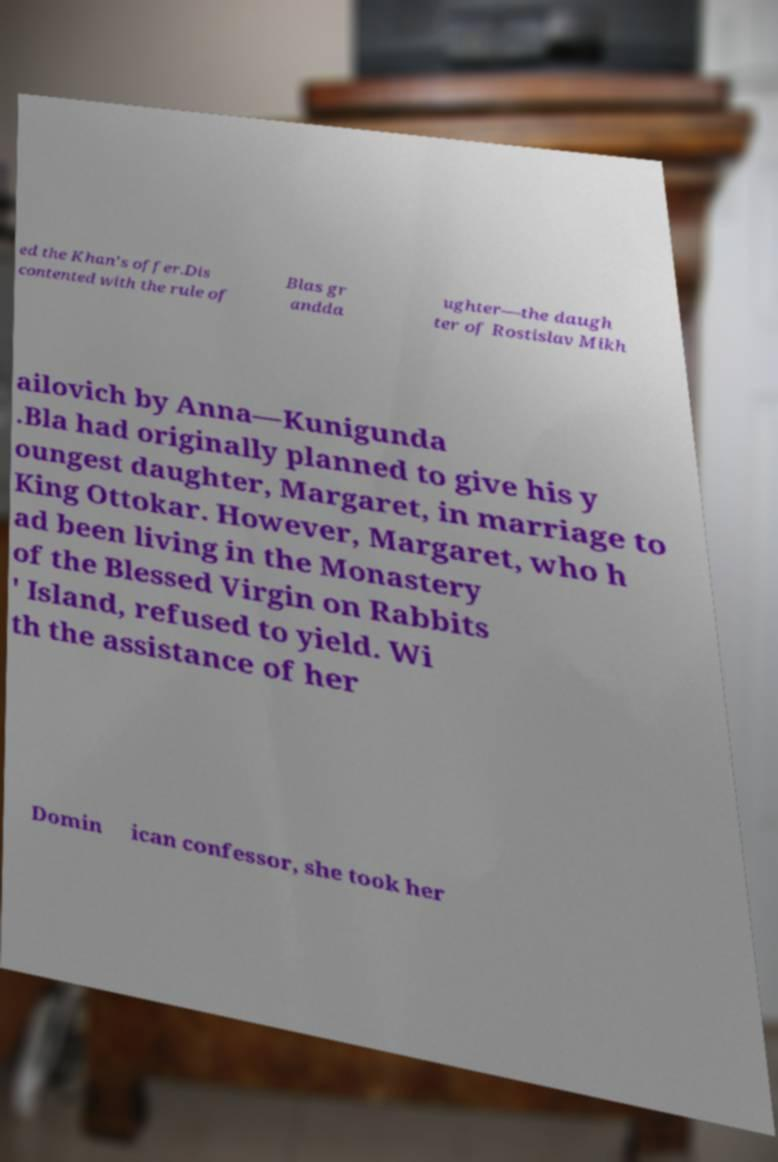Can you read and provide the text displayed in the image?This photo seems to have some interesting text. Can you extract and type it out for me? ed the Khan's offer.Dis contented with the rule of Blas gr andda ughter—the daugh ter of Rostislav Mikh ailovich by Anna—Kunigunda .Bla had originally planned to give his y oungest daughter, Margaret, in marriage to King Ottokar. However, Margaret, who h ad been living in the Monastery of the Blessed Virgin on Rabbits ' Island, refused to yield. Wi th the assistance of her Domin ican confessor, she took her 